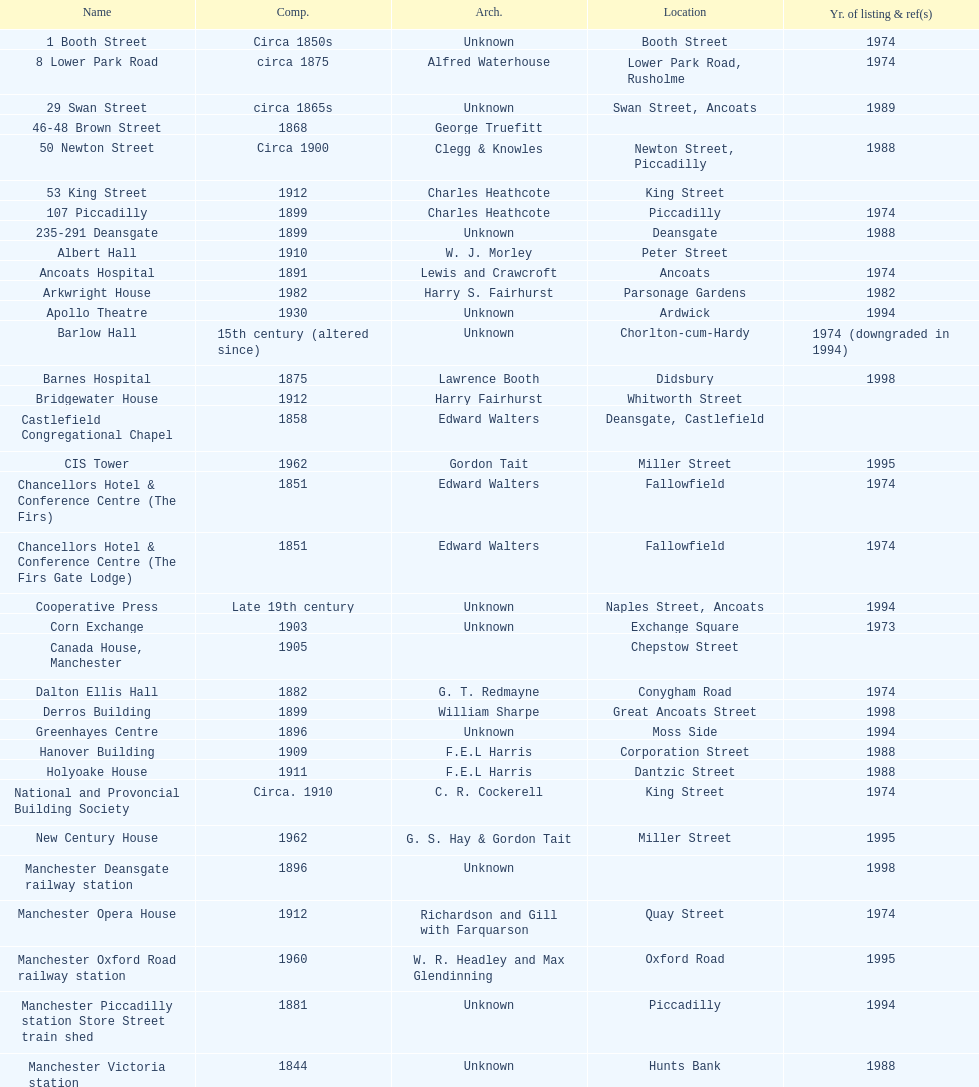What is the street of the only building listed in 1989? Swan Street. 